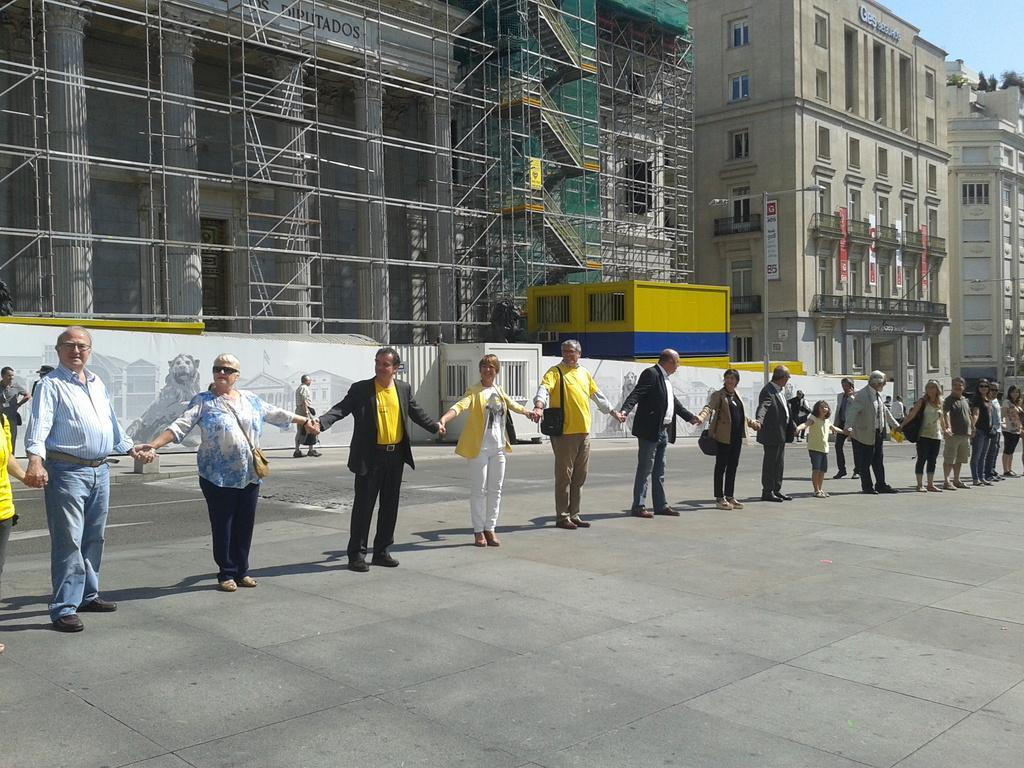How would you summarize this image in a sentence or two? In this image, we can see some people standing in a queue, they are holding each other hand, in the background, we can see some buildings, on the right side top we can see the sky. 